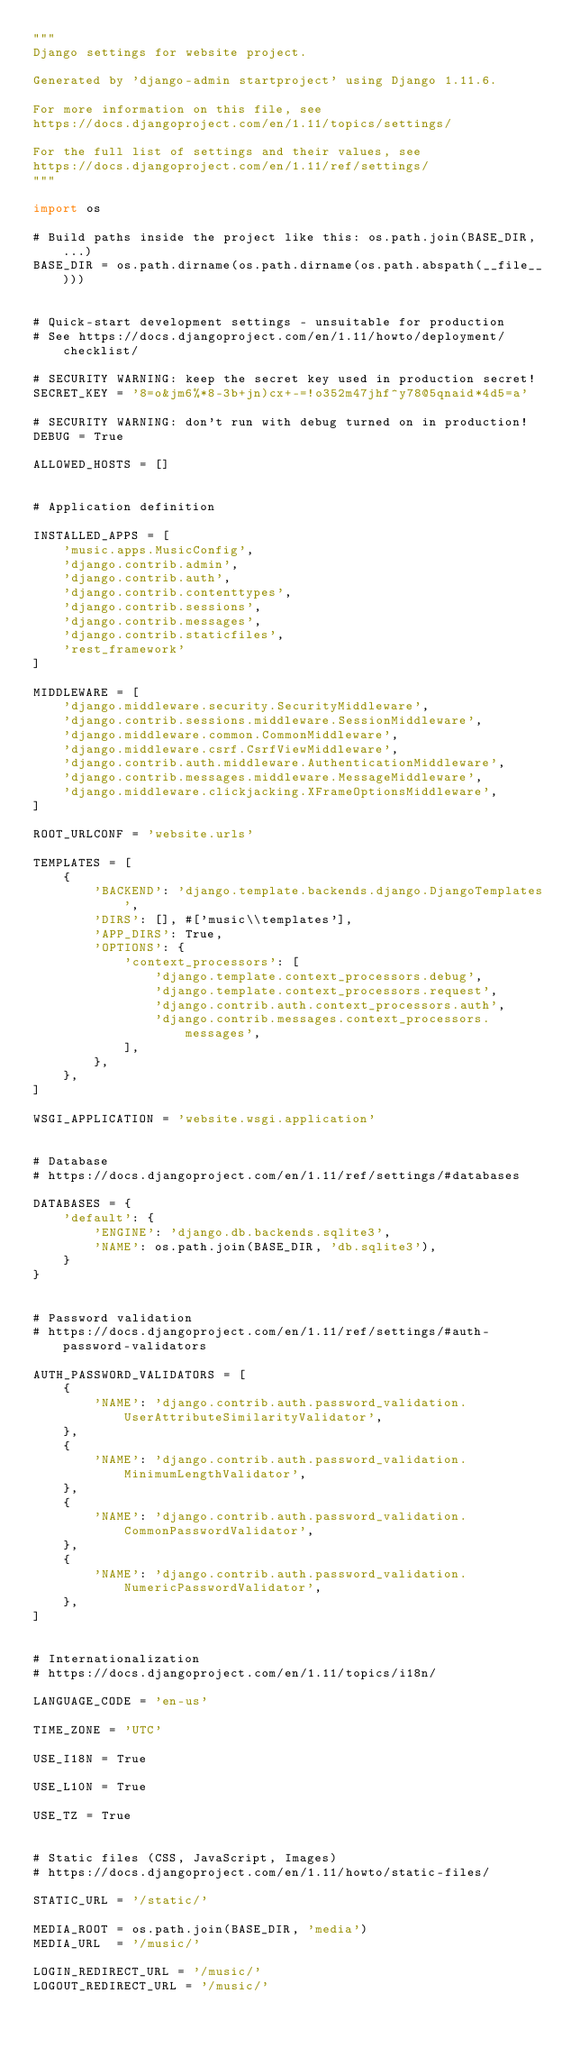Convert code to text. <code><loc_0><loc_0><loc_500><loc_500><_Python_>"""
Django settings for website project.

Generated by 'django-admin startproject' using Django 1.11.6.

For more information on this file, see
https://docs.djangoproject.com/en/1.11/topics/settings/

For the full list of settings and their values, see
https://docs.djangoproject.com/en/1.11/ref/settings/
"""

import os

# Build paths inside the project like this: os.path.join(BASE_DIR, ...)
BASE_DIR = os.path.dirname(os.path.dirname(os.path.abspath(__file__)))


# Quick-start development settings - unsuitable for production
# See https://docs.djangoproject.com/en/1.11/howto/deployment/checklist/

# SECURITY WARNING: keep the secret key used in production secret!
SECRET_KEY = '8=o&jm6%*8-3b+jn)cx+-=!o352m47jhf^y78@5qnaid*4d5=a'

# SECURITY WARNING: don't run with debug turned on in production!
DEBUG = True

ALLOWED_HOSTS = []


# Application definition

INSTALLED_APPS = [
    'music.apps.MusicConfig',
    'django.contrib.admin',
    'django.contrib.auth',
    'django.contrib.contenttypes',
    'django.contrib.sessions',
    'django.contrib.messages',
    'django.contrib.staticfiles',
    'rest_framework'
]

MIDDLEWARE = [
    'django.middleware.security.SecurityMiddleware',
    'django.contrib.sessions.middleware.SessionMiddleware',
    'django.middleware.common.CommonMiddleware',
    'django.middleware.csrf.CsrfViewMiddleware',
    'django.contrib.auth.middleware.AuthenticationMiddleware',
    'django.contrib.messages.middleware.MessageMiddleware',
    'django.middleware.clickjacking.XFrameOptionsMiddleware',
]

ROOT_URLCONF = 'website.urls'

TEMPLATES = [
    {
        'BACKEND': 'django.template.backends.django.DjangoTemplates',
        'DIRS': [], #['music\\templates'],
        'APP_DIRS': True,
        'OPTIONS': {
            'context_processors': [
                'django.template.context_processors.debug',
                'django.template.context_processors.request',
                'django.contrib.auth.context_processors.auth',
                'django.contrib.messages.context_processors.messages',
            ],
        },
    },
]

WSGI_APPLICATION = 'website.wsgi.application'


# Database
# https://docs.djangoproject.com/en/1.11/ref/settings/#databases

DATABASES = {
    'default': {
        'ENGINE': 'django.db.backends.sqlite3',
        'NAME': os.path.join(BASE_DIR, 'db.sqlite3'),
    }
}


# Password validation
# https://docs.djangoproject.com/en/1.11/ref/settings/#auth-password-validators

AUTH_PASSWORD_VALIDATORS = [
    {
        'NAME': 'django.contrib.auth.password_validation.UserAttributeSimilarityValidator',
    },
    {
        'NAME': 'django.contrib.auth.password_validation.MinimumLengthValidator',
    },
    {
        'NAME': 'django.contrib.auth.password_validation.CommonPasswordValidator',
    },
    {
        'NAME': 'django.contrib.auth.password_validation.NumericPasswordValidator',
    },
]


# Internationalization
# https://docs.djangoproject.com/en/1.11/topics/i18n/

LANGUAGE_CODE = 'en-us'

TIME_ZONE = 'UTC'

USE_I18N = True

USE_L10N = True

USE_TZ = True


# Static files (CSS, JavaScript, Images)
# https://docs.djangoproject.com/en/1.11/howto/static-files/

STATIC_URL = '/static/'

MEDIA_ROOT = os.path.join(BASE_DIR, 'media')
MEDIA_URL  = '/music/'

LOGIN_REDIRECT_URL = '/music/'
LOGOUT_REDIRECT_URL = '/music/'</code> 